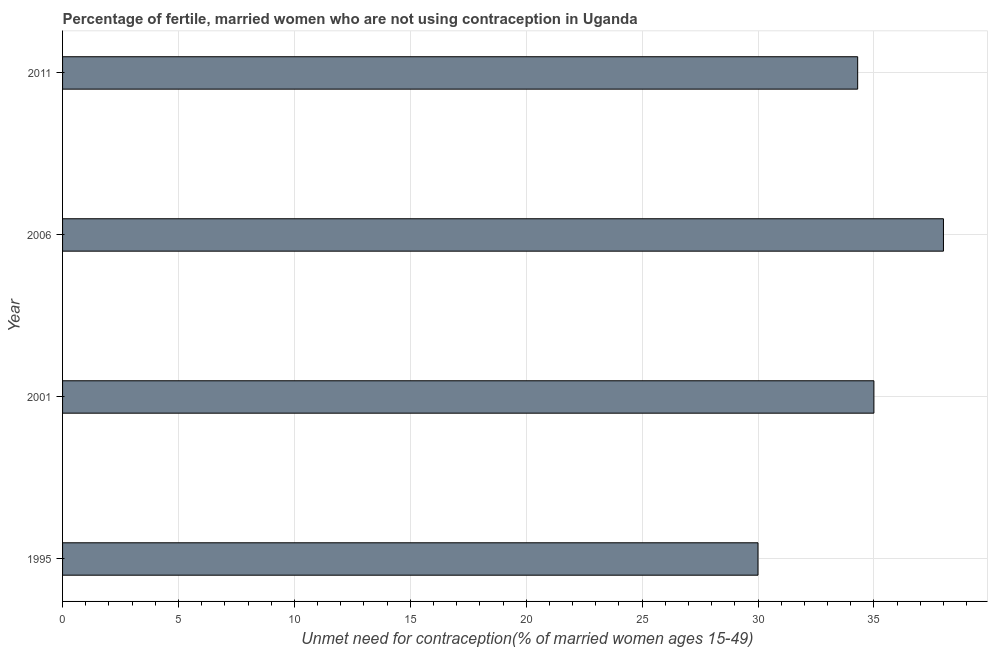Does the graph contain any zero values?
Your answer should be very brief. No. What is the title of the graph?
Make the answer very short. Percentage of fertile, married women who are not using contraception in Uganda. What is the label or title of the X-axis?
Offer a very short reply.  Unmet need for contraception(% of married women ages 15-49). What is the number of married women who are not using contraception in 2006?
Offer a very short reply. 38. Across all years, what is the minimum number of married women who are not using contraception?
Your answer should be compact. 30. In which year was the number of married women who are not using contraception maximum?
Offer a terse response. 2006. What is the sum of the number of married women who are not using contraception?
Provide a succinct answer. 137.3. What is the average number of married women who are not using contraception per year?
Provide a short and direct response. 34.33. What is the median number of married women who are not using contraception?
Make the answer very short. 34.65. In how many years, is the number of married women who are not using contraception greater than 8 %?
Give a very brief answer. 4. What is the ratio of the number of married women who are not using contraception in 2001 to that in 2006?
Provide a succinct answer. 0.92. Is the difference between the number of married women who are not using contraception in 2001 and 2011 greater than the difference between any two years?
Give a very brief answer. No. What is the difference between the highest and the second highest number of married women who are not using contraception?
Provide a short and direct response. 3. How many bars are there?
Your answer should be very brief. 4. Are all the bars in the graph horizontal?
Make the answer very short. Yes. What is the difference between two consecutive major ticks on the X-axis?
Provide a succinct answer. 5. Are the values on the major ticks of X-axis written in scientific E-notation?
Provide a succinct answer. No. What is the  Unmet need for contraception(% of married women ages 15-49) of 2006?
Offer a terse response. 38. What is the  Unmet need for contraception(% of married women ages 15-49) of 2011?
Ensure brevity in your answer.  34.3. What is the difference between the  Unmet need for contraception(% of married women ages 15-49) in 1995 and 2001?
Provide a short and direct response. -5. What is the difference between the  Unmet need for contraception(% of married women ages 15-49) in 2001 and 2006?
Provide a short and direct response. -3. What is the difference between the  Unmet need for contraception(% of married women ages 15-49) in 2001 and 2011?
Provide a succinct answer. 0.7. What is the difference between the  Unmet need for contraception(% of married women ages 15-49) in 2006 and 2011?
Offer a very short reply. 3.7. What is the ratio of the  Unmet need for contraception(% of married women ages 15-49) in 1995 to that in 2001?
Provide a succinct answer. 0.86. What is the ratio of the  Unmet need for contraception(% of married women ages 15-49) in 1995 to that in 2006?
Give a very brief answer. 0.79. What is the ratio of the  Unmet need for contraception(% of married women ages 15-49) in 2001 to that in 2006?
Provide a succinct answer. 0.92. What is the ratio of the  Unmet need for contraception(% of married women ages 15-49) in 2001 to that in 2011?
Provide a short and direct response. 1.02. What is the ratio of the  Unmet need for contraception(% of married women ages 15-49) in 2006 to that in 2011?
Make the answer very short. 1.11. 